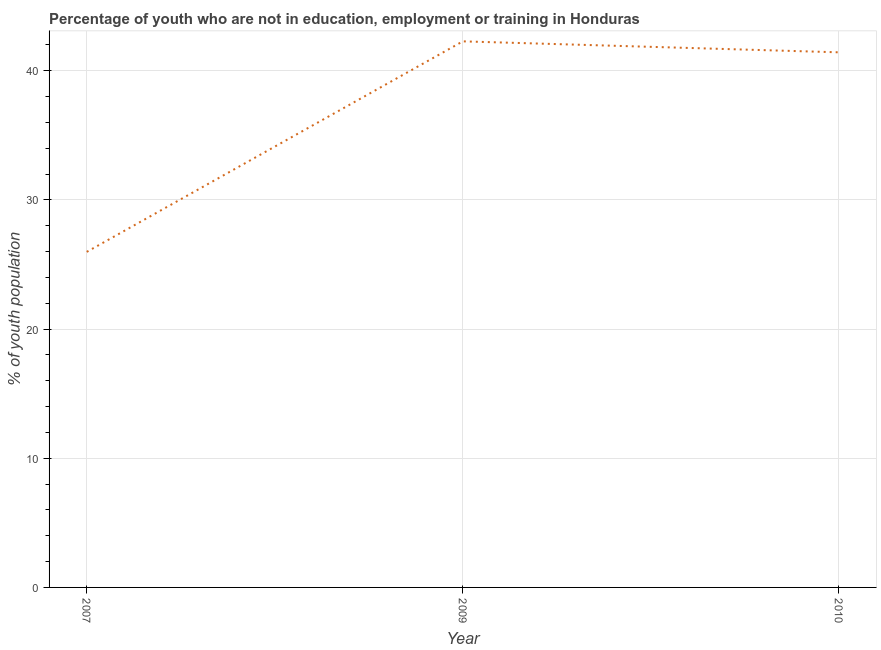What is the unemployed youth population in 2010?
Keep it short and to the point. 41.43. Across all years, what is the maximum unemployed youth population?
Provide a short and direct response. 42.28. Across all years, what is the minimum unemployed youth population?
Give a very brief answer. 25.98. In which year was the unemployed youth population maximum?
Your response must be concise. 2009. In which year was the unemployed youth population minimum?
Your answer should be very brief. 2007. What is the sum of the unemployed youth population?
Your answer should be very brief. 109.69. What is the difference between the unemployed youth population in 2007 and 2010?
Your response must be concise. -15.45. What is the average unemployed youth population per year?
Offer a very short reply. 36.56. What is the median unemployed youth population?
Ensure brevity in your answer.  41.43. In how many years, is the unemployed youth population greater than 14 %?
Offer a terse response. 3. Do a majority of the years between 2009 and 2010 (inclusive) have unemployed youth population greater than 22 %?
Offer a very short reply. Yes. What is the ratio of the unemployed youth population in 2007 to that in 2010?
Provide a succinct answer. 0.63. Is the difference between the unemployed youth population in 2007 and 2010 greater than the difference between any two years?
Offer a very short reply. No. What is the difference between the highest and the second highest unemployed youth population?
Your answer should be compact. 0.85. What is the difference between the highest and the lowest unemployed youth population?
Give a very brief answer. 16.3. How many lines are there?
Your answer should be very brief. 1. What is the difference between two consecutive major ticks on the Y-axis?
Provide a short and direct response. 10. Does the graph contain grids?
Provide a short and direct response. Yes. What is the title of the graph?
Your answer should be compact. Percentage of youth who are not in education, employment or training in Honduras. What is the label or title of the X-axis?
Offer a terse response. Year. What is the label or title of the Y-axis?
Keep it short and to the point. % of youth population. What is the % of youth population of 2007?
Your answer should be very brief. 25.98. What is the % of youth population of 2009?
Your answer should be compact. 42.28. What is the % of youth population in 2010?
Your response must be concise. 41.43. What is the difference between the % of youth population in 2007 and 2009?
Keep it short and to the point. -16.3. What is the difference between the % of youth population in 2007 and 2010?
Your answer should be compact. -15.45. What is the ratio of the % of youth population in 2007 to that in 2009?
Your response must be concise. 0.61. What is the ratio of the % of youth population in 2007 to that in 2010?
Your answer should be compact. 0.63. 